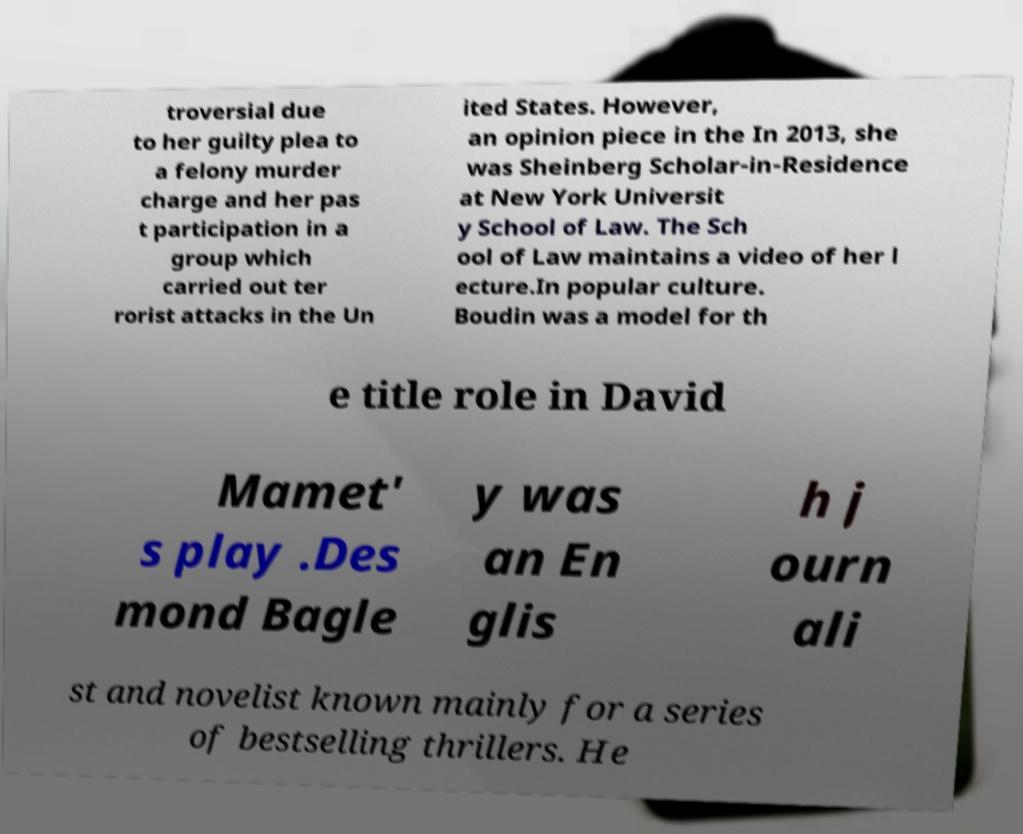What messages or text are displayed in this image? I need them in a readable, typed format. troversial due to her guilty plea to a felony murder charge and her pas t participation in a group which carried out ter rorist attacks in the Un ited States. However, an opinion piece in the In 2013, she was Sheinberg Scholar-in-Residence at New York Universit y School of Law. The Sch ool of Law maintains a video of her l ecture.In popular culture. Boudin was a model for th e title role in David Mamet' s play .Des mond Bagle y was an En glis h j ourn ali st and novelist known mainly for a series of bestselling thrillers. He 